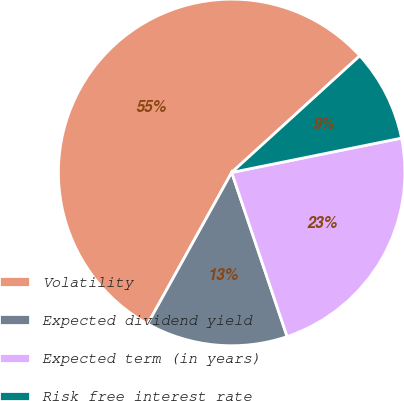Convert chart to OTSL. <chart><loc_0><loc_0><loc_500><loc_500><pie_chart><fcel>Volatility<fcel>Expected dividend yield<fcel>Expected term (in years)<fcel>Risk free interest rate<nl><fcel>55.18%<fcel>13.24%<fcel>22.99%<fcel>8.58%<nl></chart> 